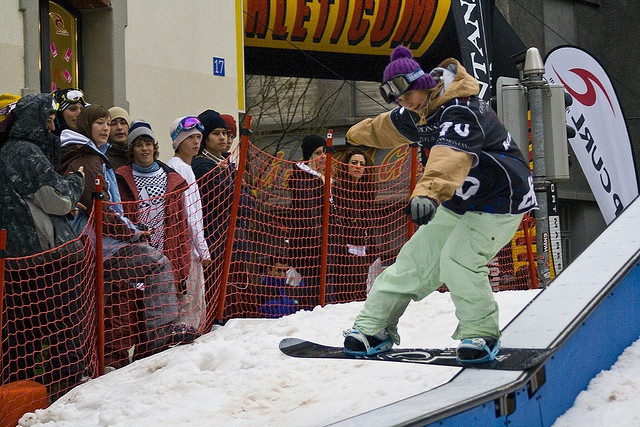Describe the objects in this image and their specific colors. I can see people in darkgray, black, gray, and olive tones, people in darkgray, black, gray, and purple tones, people in darkgray, black, gray, maroon, and brown tones, snowboard in darkgray, black, and maroon tones, and people in darkgray, maroon, black, and gray tones in this image. 